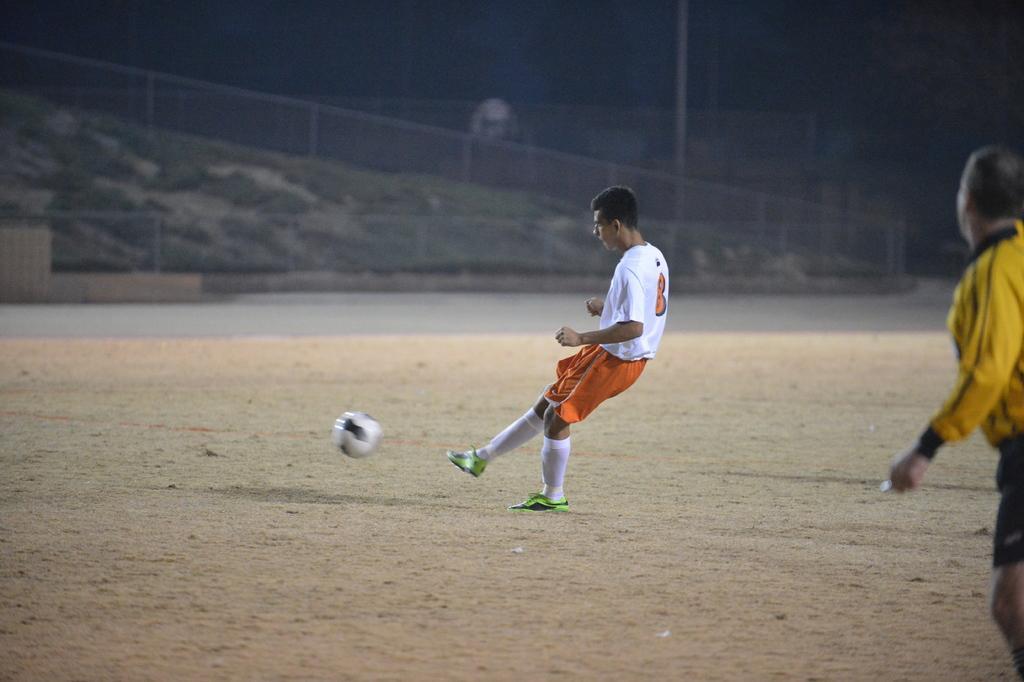In one or two sentences, can you explain what this image depicts? In this picture there is a boy wearing a white color t-shirt and orange track playing football in the ground. Behind there is an another man wearing yellow color t-shirt and running. In the background there is a fencing grill and a grass hill. 